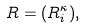<formula> <loc_0><loc_0><loc_500><loc_500>R = ( R _ { i } ^ { \kappa } ) ,</formula> 